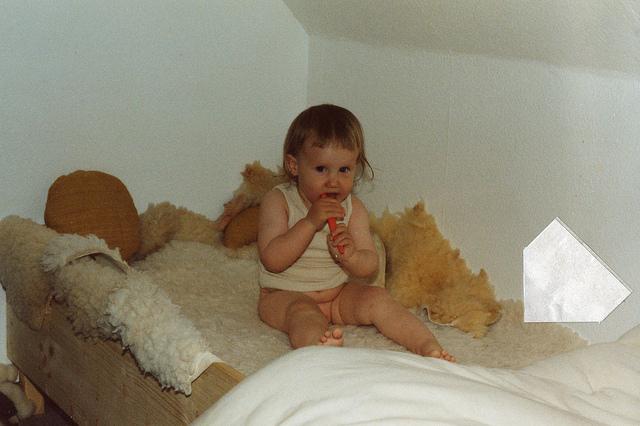Are the walls decorated?
Short answer required. No. What is the child sitting on?
Write a very short answer. Bed. How many children are there?
Quick response, please. 1. 